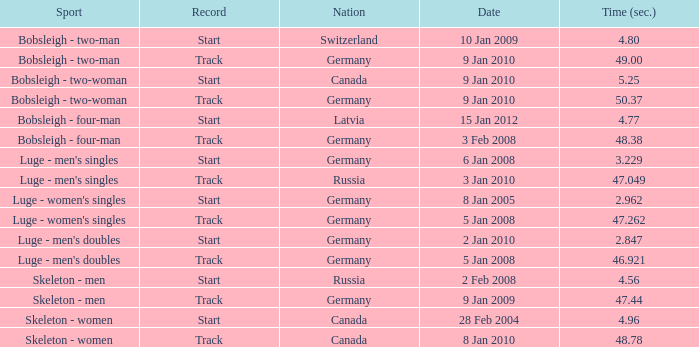Which state ended with a time of 4 Russia. Parse the table in full. {'header': ['Sport', 'Record', 'Nation', 'Date', 'Time (sec.)'], 'rows': [['Bobsleigh - two-man', 'Start', 'Switzerland', '10 Jan 2009', '4.80'], ['Bobsleigh - two-man', 'Track', 'Germany', '9 Jan 2010', '49.00'], ['Bobsleigh - two-woman', 'Start', 'Canada', '9 Jan 2010', '5.25'], ['Bobsleigh - two-woman', 'Track', 'Germany', '9 Jan 2010', '50.37'], ['Bobsleigh - four-man', 'Start', 'Latvia', '15 Jan 2012', '4.77'], ['Bobsleigh - four-man', 'Track', 'Germany', '3 Feb 2008', '48.38'], ["Luge - men's singles", 'Start', 'Germany', '6 Jan 2008', '3.229'], ["Luge - men's singles", 'Track', 'Russia', '3 Jan 2010', '47.049'], ["Luge - women's singles", 'Start', 'Germany', '8 Jan 2005', '2.962'], ["Luge - women's singles", 'Track', 'Germany', '5 Jan 2008', '47.262'], ["Luge - men's doubles", 'Start', 'Germany', '2 Jan 2010', '2.847'], ["Luge - men's doubles", 'Track', 'Germany', '5 Jan 2008', '46.921'], ['Skeleton - men', 'Start', 'Russia', '2 Feb 2008', '4.56'], ['Skeleton - men', 'Track', 'Germany', '9 Jan 2009', '47.44'], ['Skeleton - women', 'Start', 'Canada', '28 Feb 2004', '4.96'], ['Skeleton - women', 'Track', 'Canada', '8 Jan 2010', '48.78']]} 